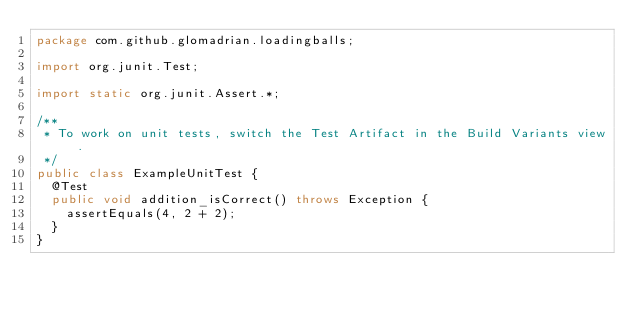<code> <loc_0><loc_0><loc_500><loc_500><_Java_>package com.github.glomadrian.loadingballs;

import org.junit.Test;

import static org.junit.Assert.*;

/**
 * To work on unit tests, switch the Test Artifact in the Build Variants view.
 */
public class ExampleUnitTest {
  @Test
  public void addition_isCorrect() throws Exception {
    assertEquals(4, 2 + 2);
  }
}</code> 